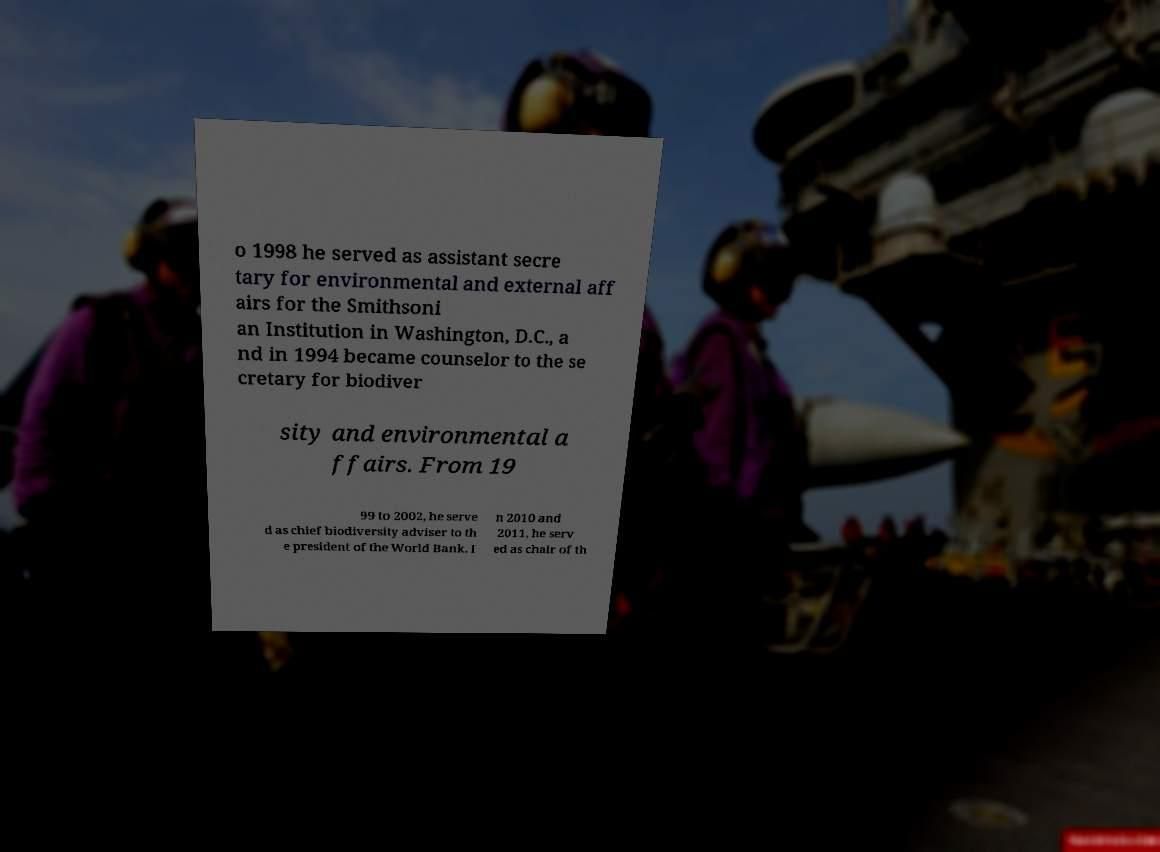I need the written content from this picture converted into text. Can you do that? o 1998 he served as assistant secre tary for environmental and external aff airs for the Smithsoni an Institution in Washington, D.C., a nd in 1994 became counselor to the se cretary for biodiver sity and environmental a ffairs. From 19 99 to 2002, he serve d as chief biodiversity adviser to th e president of the World Bank. I n 2010 and 2011, he serv ed as chair of th 